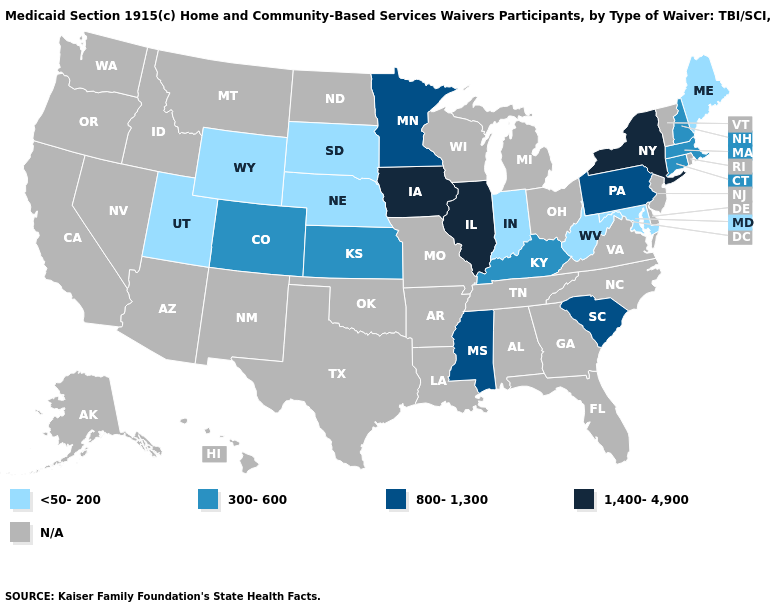Is the legend a continuous bar?
Quick response, please. No. What is the value of Maine?
Short answer required. <50-200. What is the value of Arizona?
Concise answer only. N/A. Does Connecticut have the lowest value in the USA?
Give a very brief answer. No. Among the states that border Maryland , which have the highest value?
Write a very short answer. Pennsylvania. Name the states that have a value in the range <50-200?
Be succinct. Indiana, Maine, Maryland, Nebraska, South Dakota, Utah, West Virginia, Wyoming. Name the states that have a value in the range 300-600?
Write a very short answer. Colorado, Connecticut, Kansas, Kentucky, Massachusetts, New Hampshire. Does the map have missing data?
Short answer required. Yes. What is the highest value in the USA?
Quick response, please. 1,400-4,900. Name the states that have a value in the range 800-1,300?
Quick response, please. Minnesota, Mississippi, Pennsylvania, South Carolina. Which states have the lowest value in the West?
Short answer required. Utah, Wyoming. What is the value of New Hampshire?
Keep it brief. 300-600. Name the states that have a value in the range N/A?
Short answer required. Alabama, Alaska, Arizona, Arkansas, California, Delaware, Florida, Georgia, Hawaii, Idaho, Louisiana, Michigan, Missouri, Montana, Nevada, New Jersey, New Mexico, North Carolina, North Dakota, Ohio, Oklahoma, Oregon, Rhode Island, Tennessee, Texas, Vermont, Virginia, Washington, Wisconsin. What is the lowest value in states that border Maine?
Write a very short answer. 300-600. Which states have the lowest value in the West?
Quick response, please. Utah, Wyoming. 